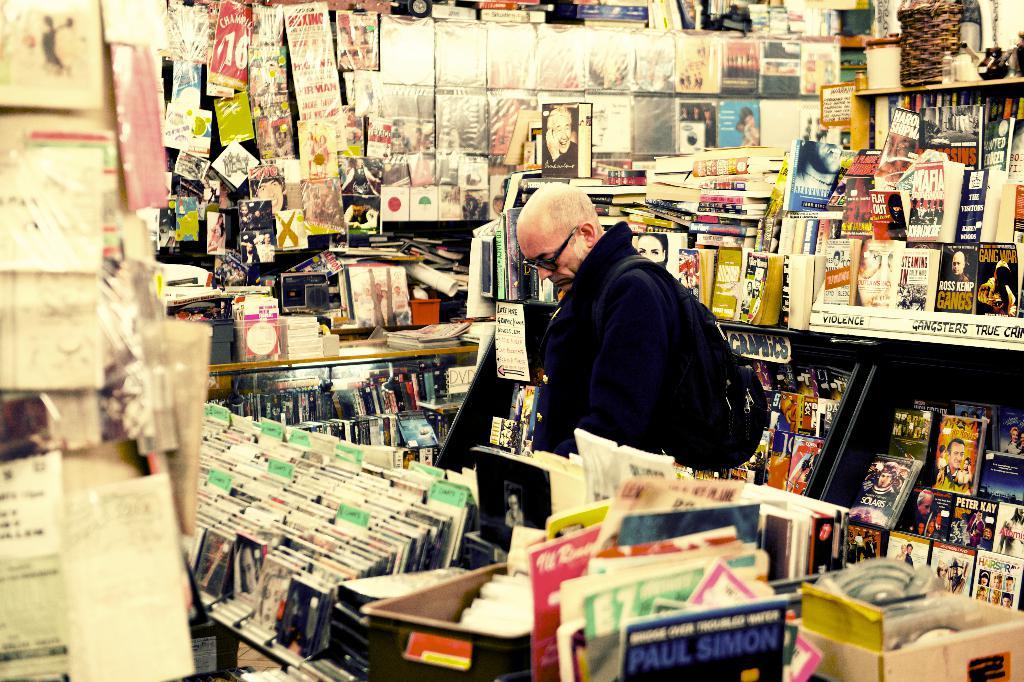What section is to the left of gangsters true crime?
Offer a terse response. Violence. What famous musician is seen in blue font on the album on the bottom of the photo?
Give a very brief answer. Paul simon. 